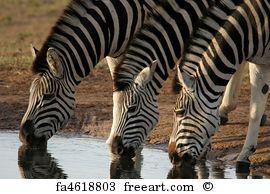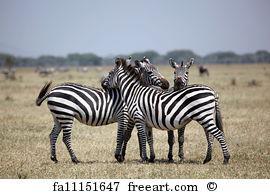The first image is the image on the left, the second image is the image on the right. Examine the images to the left and right. Is the description "there are 6 zebras in the image pair" accurate? Answer yes or no. Yes. The first image is the image on the left, the second image is the image on the right. Given the left and right images, does the statement "Each image contains exactly three foreground zebra that are close together in similar poses." hold true? Answer yes or no. Yes. 